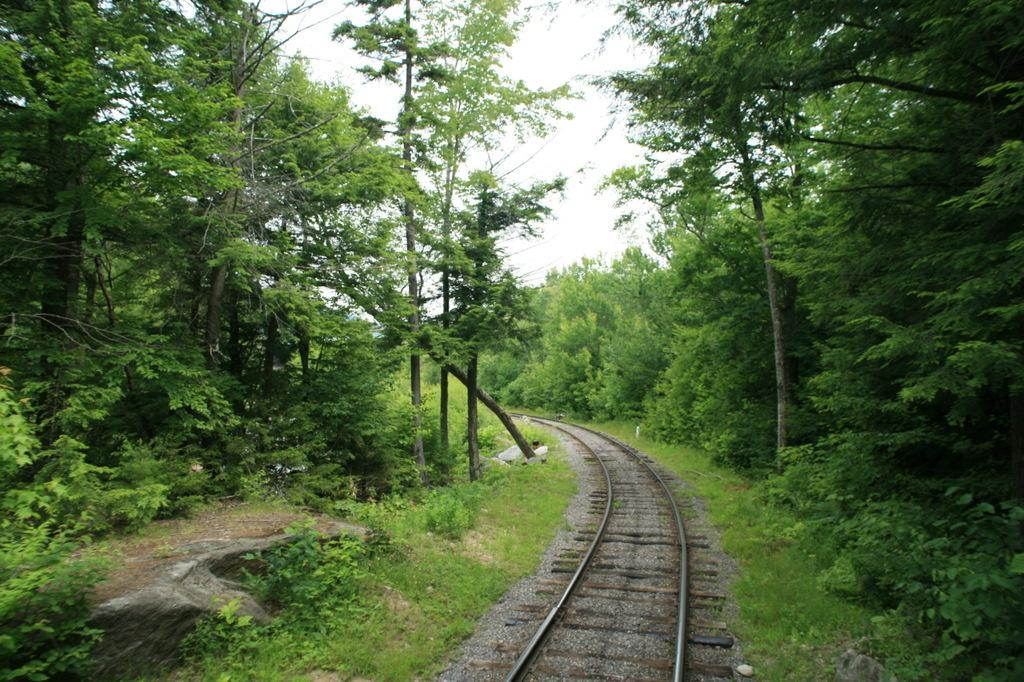What is the main feature of the image? There is a railway track in the image. What can be seen on either side of the railway track? Plants and trees are visible on either side of the railway track. What is visible in the background of the image? The sky is visible in the background of the image. Who is the owner of the railway track in the image? There is no information about the owner of the railway track in the image. 